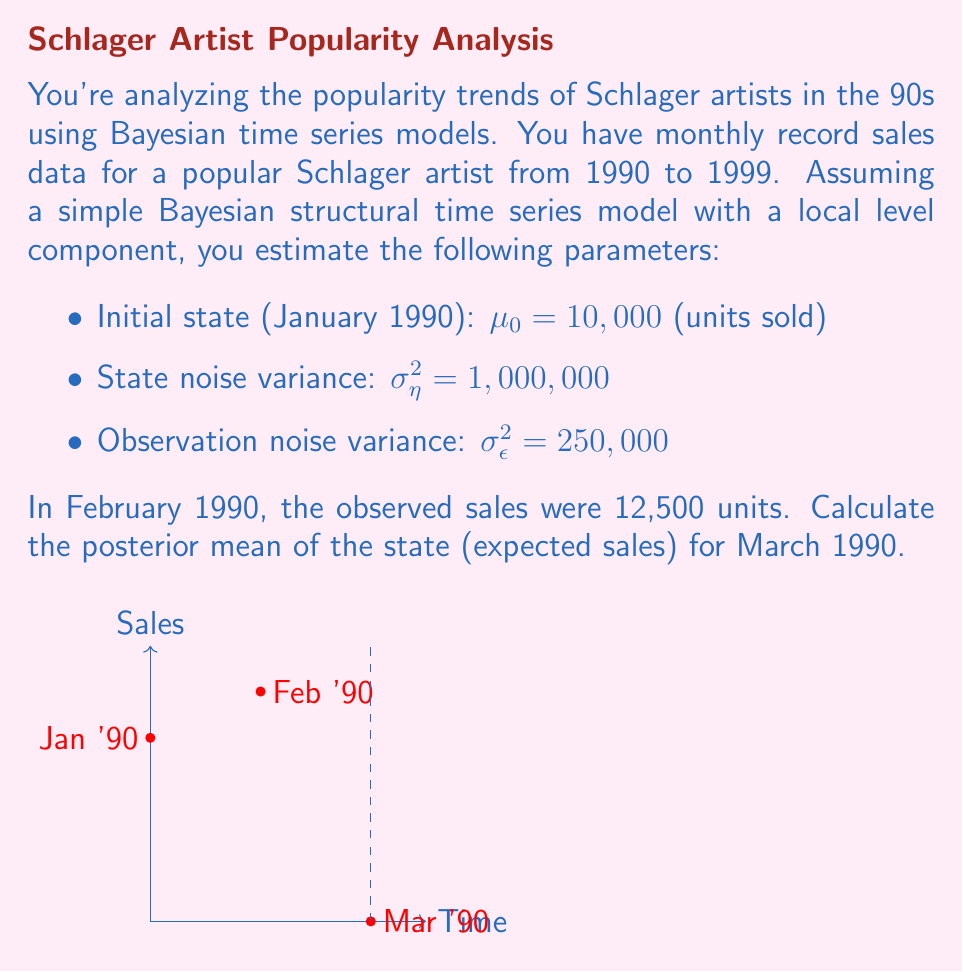Solve this math problem. Let's approach this step-by-step using the Kalman filter equations for Bayesian structural time series:

1) First, we need to calculate the Kalman gain. The formula is:

   $$K_t = \frac{P_{t|t-1}}{P_{t|t-1} + \sigma^2_\epsilon}$$

   where $P_{t|t-1}$ is the prior variance of the state.

2) For the first time step, $P_{1|0} = \sigma^2_\eta = 1,000,000$. So:

   $$K_1 = \frac{1,000,000}{1,000,000 + 250,000} = 0.8$$

3) Now we can update our estimate of the state for February:

   $$\mu_{1|1} = \mu_{1|0} + K_1(y_1 - \mu_{1|0})$$
   $$\mu_{1|1} = 10,000 + 0.8(12,500 - 10,000) = 12,000$$

4) The posterior variance for February is:

   $$P_{1|1} = (1 - K_1)P_{1|0} = 0.2 * 1,000,000 = 200,000$$

5) For March, our prior mean is the same as the posterior mean for February:

   $$\mu_{2|1} = \mu_{1|1} = 12,000$$

6) The prior variance for March is:

   $$P_{2|1} = P_{1|1} + \sigma^2_\eta = 200,000 + 1,000,000 = 1,200,000$$

This is our final result. The posterior mean of the state (expected sales) for March 1990 is 12,000 units.
Answer: 12,000 units 